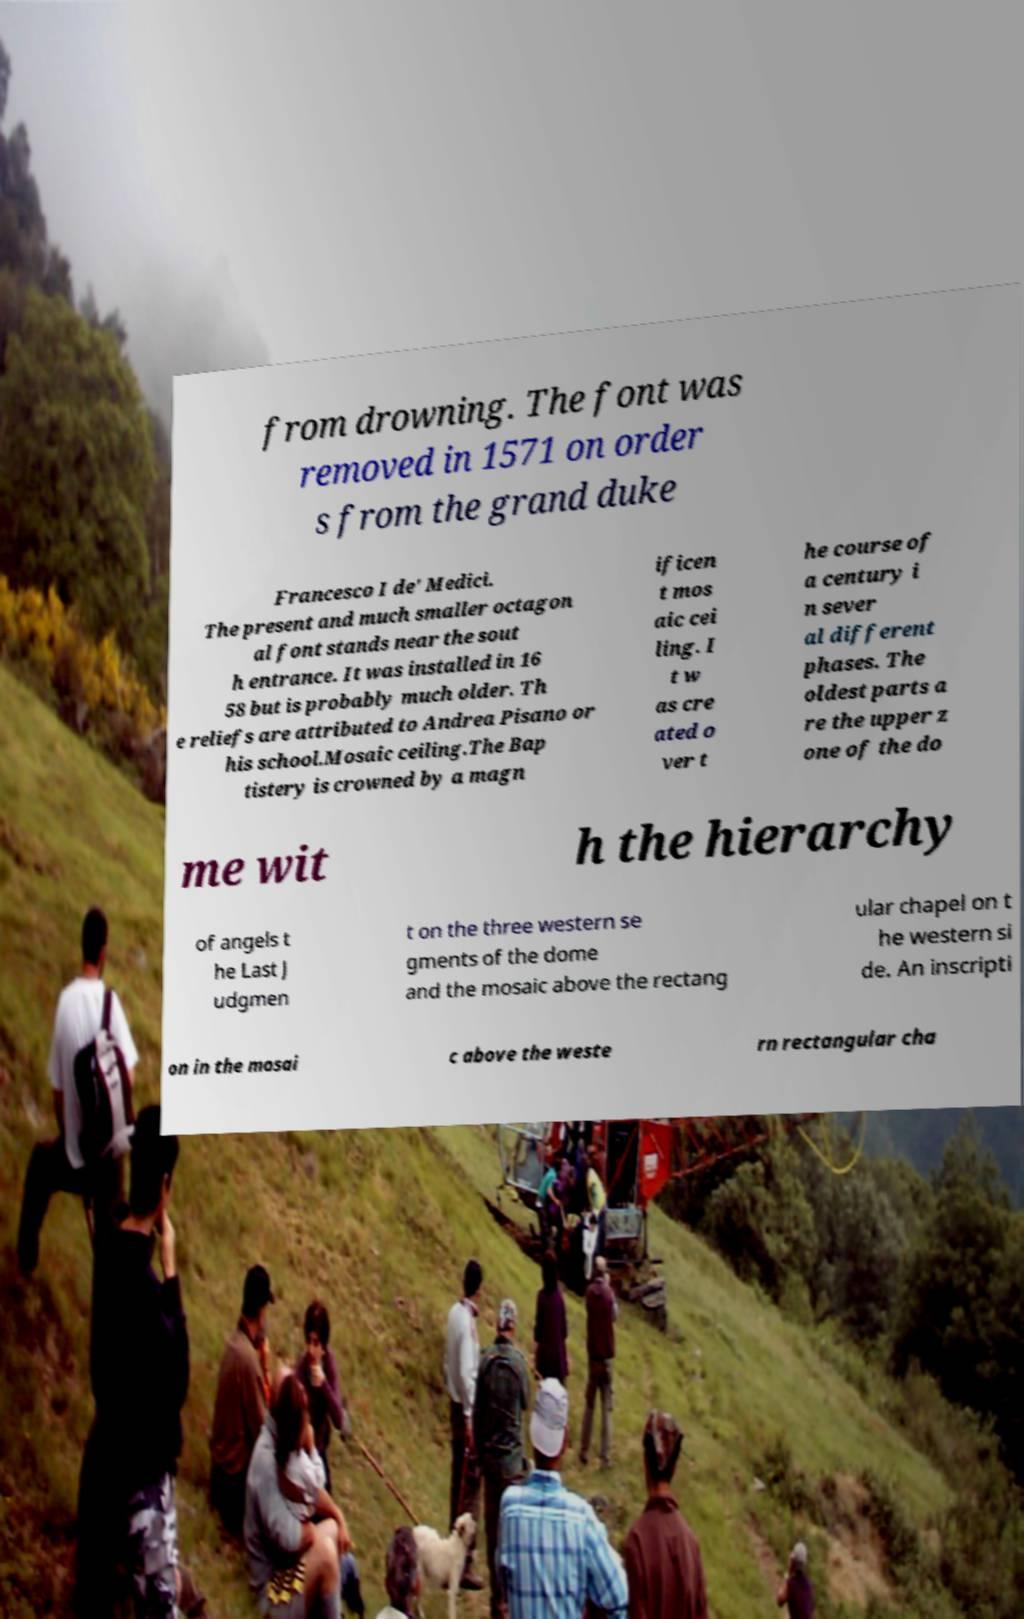What messages or text are displayed in this image? I need them in a readable, typed format. from drowning. The font was removed in 1571 on order s from the grand duke Francesco I de' Medici. The present and much smaller octagon al font stands near the sout h entrance. It was installed in 16 58 but is probably much older. Th e reliefs are attributed to Andrea Pisano or his school.Mosaic ceiling.The Bap tistery is crowned by a magn ificen t mos aic cei ling. I t w as cre ated o ver t he course of a century i n sever al different phases. The oldest parts a re the upper z one of the do me wit h the hierarchy of angels t he Last J udgmen t on the three western se gments of the dome and the mosaic above the rectang ular chapel on t he western si de. An inscripti on in the mosai c above the weste rn rectangular cha 